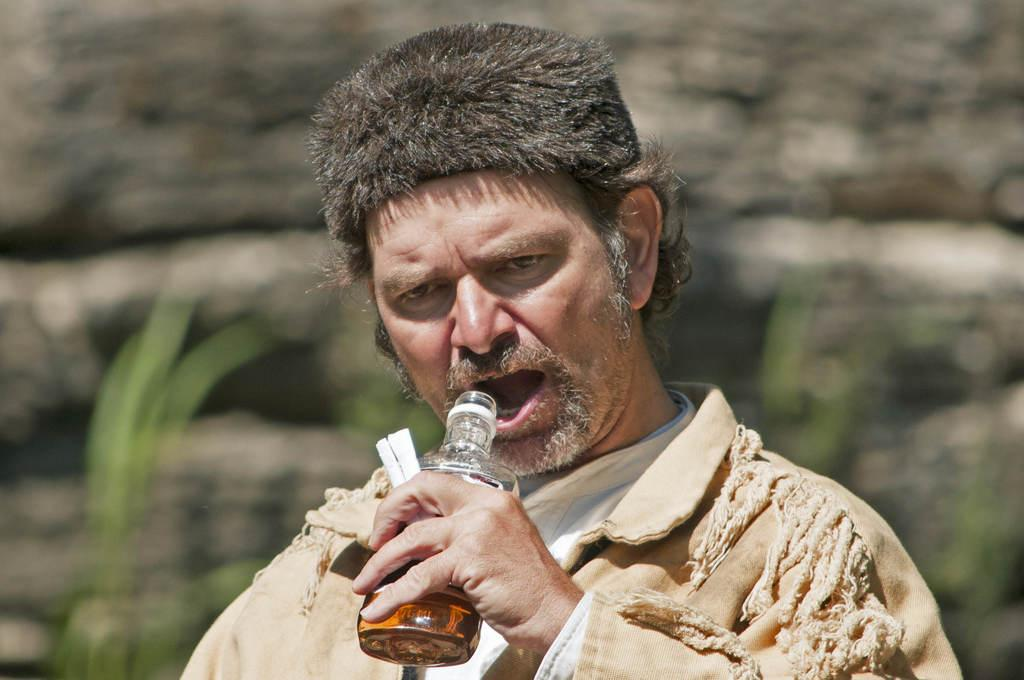What is the man in the image doing? The man is standing in the image. What is the man holding in the image? The man is holding a bottle. What can be seen in the background of the image? There are plants visible in the background of the image. What other object is present in the image? There is a rock in the image. What type of map is the man using to navigate downtown in the image? There is no map or reference to downtown in the image; it only shows a man standing with a bottle and a rock in the presence of plants. 